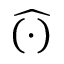<formula> <loc_0><loc_0><loc_500><loc_500>\widehat { \left ( \cdot \right ) }</formula> 